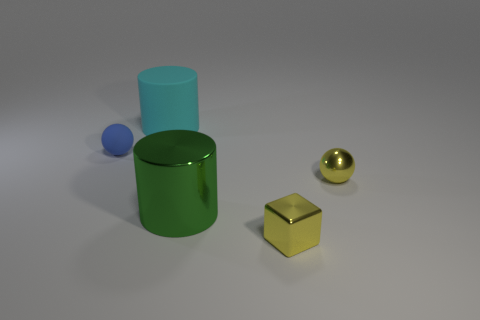Subtract 1 cubes. How many cubes are left? 0 Add 3 yellow shiny spheres. How many objects exist? 8 Subtract all cyan cylinders. How many cylinders are left? 1 Subtract all spheres. How many objects are left? 3 Subtract 0 purple balls. How many objects are left? 5 Subtract all big metallic cubes. Subtract all cylinders. How many objects are left? 3 Add 4 big matte things. How many big matte things are left? 5 Add 2 large things. How many large things exist? 4 